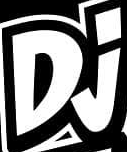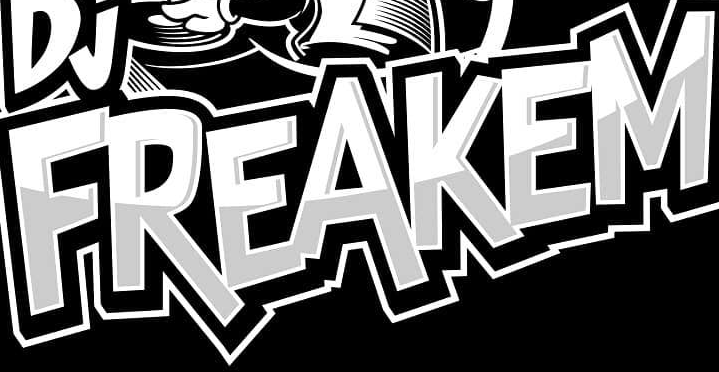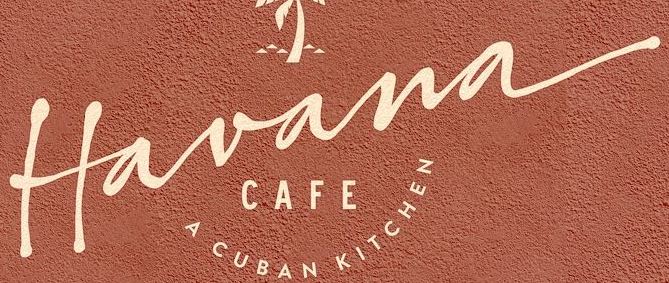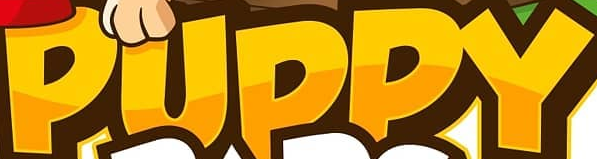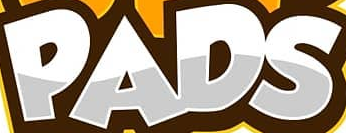Read the text content from these images in order, separated by a semicolon. Dj; FREAKEM; Havana; PUPPY; PADS 